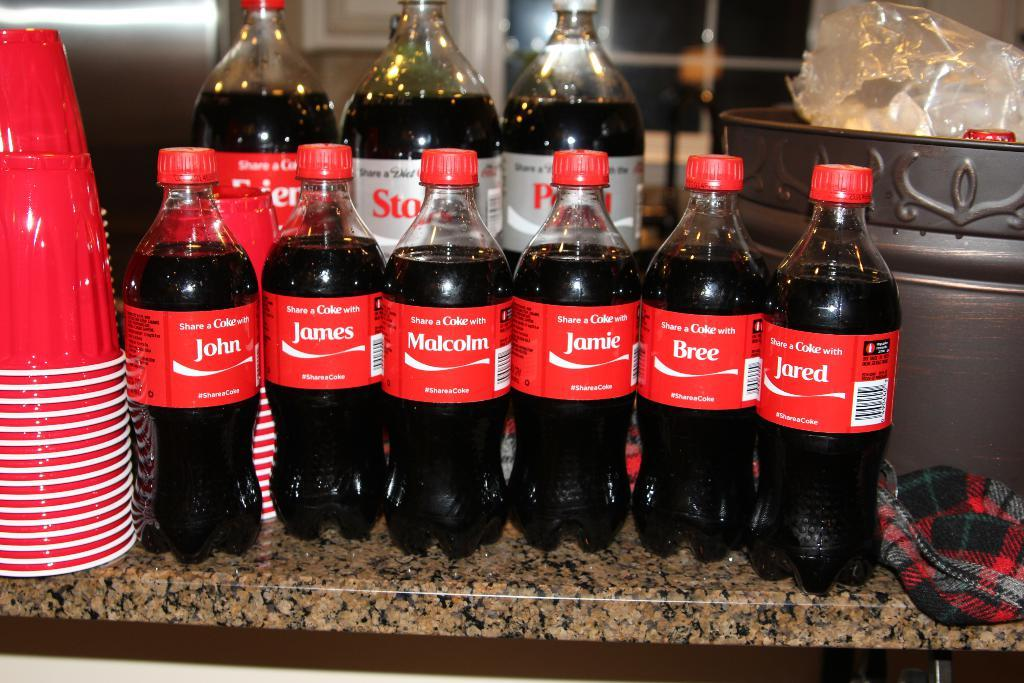What objects are present in the image that are typically used for holding liquids? There is a group of bottles and a group of cups in the image. What else can be seen in the image besides the bottles and cups? There is a container, a cloth, and a cover on the table in the image. Are there any decorative elements on the bottles? Yes, stickers are present on the bottles. What type of record is being played on the table in the image? There is no record present in the image; it only contains bottles, cups, a container, a cloth, and a cover. 